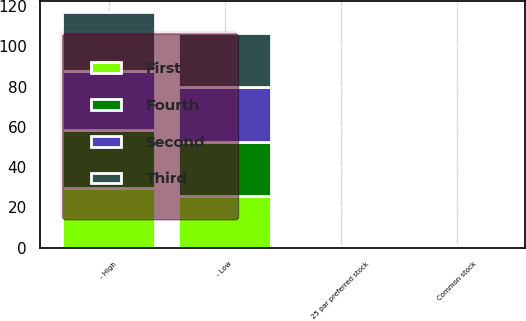<chart> <loc_0><loc_0><loc_500><loc_500><stacked_bar_chart><ecel><fcel>Common stock<fcel>25 par preferred stock<fcel>- High<fcel>- Low<nl><fcel>Fourth<fcel>0.36<fcel>0.25<fcel>28.91<fcel>26.96<nl><fcel>Second<fcel>0.36<fcel>0.25<fcel>29.14<fcel>27.35<nl><fcel>First<fcel>0.33<fcel>0.25<fcel>29.5<fcel>25.45<nl><fcel>Third<fcel>0.33<fcel>0.25<fcel>29.35<fcel>26.75<nl></chart> 